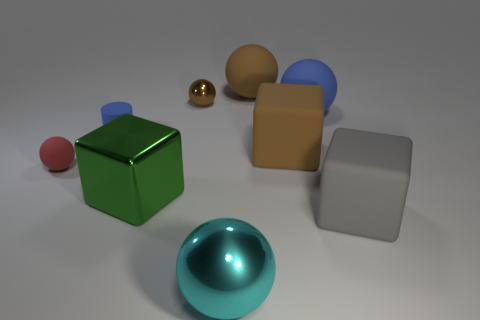Is there any other thing that is the same size as the brown shiny object?
Give a very brief answer. Yes. What is the shape of the shiny thing that is both in front of the rubber cylinder and on the right side of the green block?
Give a very brief answer. Sphere. What number of brown things are either small shiny spheres or tiny rubber cubes?
Ensure brevity in your answer.  1. Is the size of the blue matte thing to the left of the blue sphere the same as the brown matte thing that is in front of the big blue rubber thing?
Your answer should be compact. No. How many things are large purple metallic cylinders or large shiny blocks?
Provide a succinct answer. 1. Are there any other metal things that have the same shape as the green metal object?
Your response must be concise. No. Is the number of purple rubber objects less than the number of matte blocks?
Your answer should be very brief. Yes. Does the cyan thing have the same shape as the green metallic thing?
Your response must be concise. No. What number of objects are either small green shiny blocks or big green cubes that are behind the cyan ball?
Make the answer very short. 1. How many tiny purple shiny cylinders are there?
Provide a short and direct response. 0. 